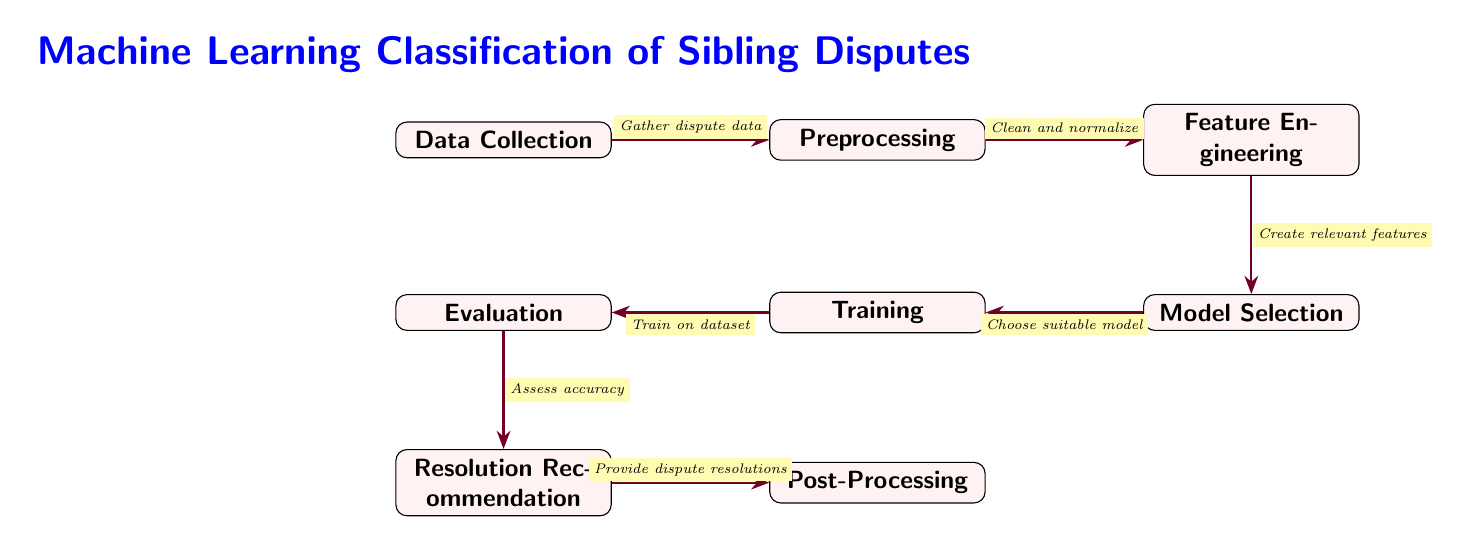What is the first step in the diagram? The first step in the diagram is labeled as "Data Collection," indicating that gathering information about disputes among siblings occurs at this stage.
Answer: Data Collection How many nodes are in the diagram? There are a total of eight nodes, which represent different steps in the classification process of sibling disputes.
Answer: Eight What happens after "Evaluation"? After "Evaluation," the next step is "Resolution Recommendation," which suggests that based on evaluation results, potential resolutions are offered.
Answer: Resolution Recommendation What is the relationship between "Preprocessing" and "Feature Engineering"? "Preprocessing" leads to "Feature Engineering," suggesting that after cleaning and normalizing the data, relevant features are created for further analysis.
Answer: Preprocessing leads to Feature Engineering Which node provides dispute resolutions? The node responsible for providing dispute resolutions is labeled "Resolution Recommendation," indicating that it outputs potential solutions to the conflicts.
Answer: Resolution Recommendation What is performed at the "Training" stage? At the "Training" stage, the model is trained on the dataset that was collected and preprocessed in the earlier stages to predict outcomes for sibling disputes.
Answer: Train on dataset What is the last step in this diagram? The last step in the diagram is "Post-Processing," which likely involves finalizing the results or refining the resolutions suggested for the disputes.
Answer: Post-Processing Which node is directly before "Post-Processing"? The node directly before "Post-Processing" is "Resolution Recommendation," which indicates that post-processing occurs after generating the resolutions based on dispute evaluations.
Answer: Resolution Recommendation What type of model is chosen during the "Model Selection" phase? During the "Model Selection" phase, a suitable machine learning model specific to the context of sibling disputes is chosen, but the exact model is not specified in the diagram.
Answer: Suitable model 